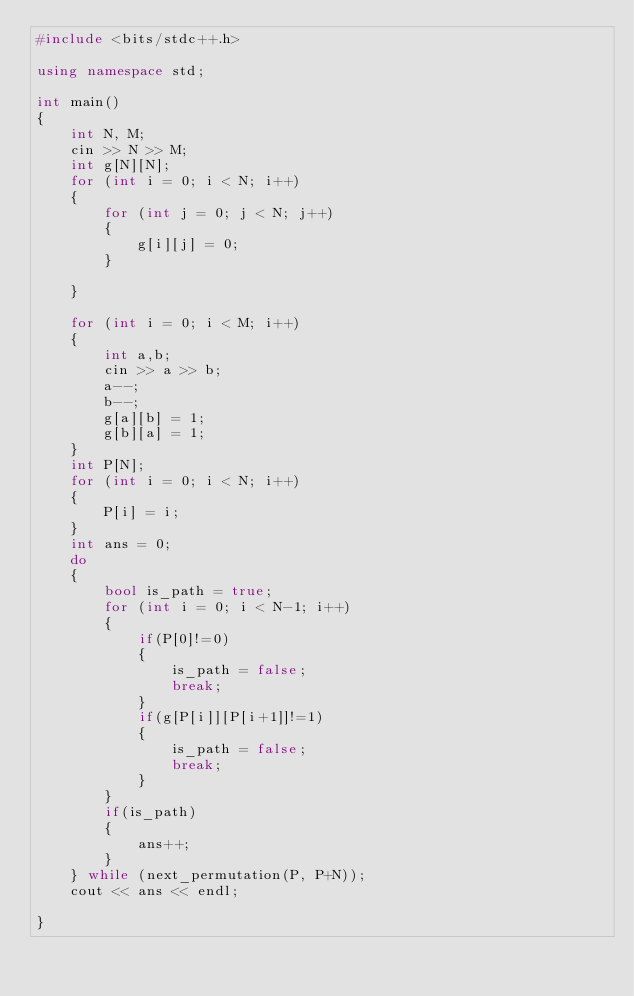<code> <loc_0><loc_0><loc_500><loc_500><_C++_>#include <bits/stdc++.h>

using namespace std;

int main()
{
    int N, M;
    cin >> N >> M;
    int g[N][N];
    for (int i = 0; i < N; i++)
    {
        for (int j = 0; j < N; j++)
        {
            g[i][j] = 0;
        }
        
    }
    
    for (int i = 0; i < M; i++)
    {
        int a,b;
        cin >> a >> b;
        a--;
        b--;
        g[a][b] = 1;
        g[b][a] = 1;
    }
    int P[N];
    for (int i = 0; i < N; i++)
    {
        P[i] = i;
    }
    int ans = 0;
    do
    {   
        bool is_path = true;
        for (int i = 0; i < N-1; i++)
        {
            if(P[0]!=0)
            {
                is_path = false;
                break;
            }
            if(g[P[i]][P[i+1]]!=1)
            {
                is_path = false;
                break;
            }
        }
        if(is_path)
        {
            ans++;
        }
    } while (next_permutation(P, P+N));
    cout << ans << endl;
    
}
</code> 